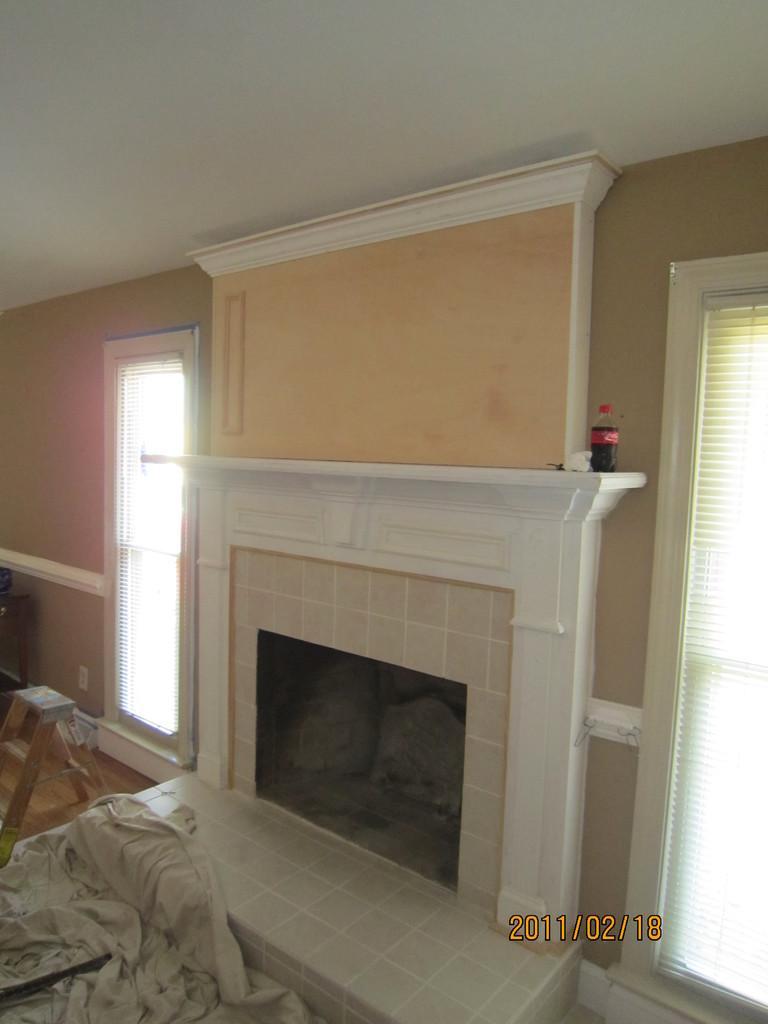Please provide a concise description of this image. At the bottom of the image there is date, in this image there is a fireplace, on the fireplace platform, there are some objects, beside the fireplace there are windows with curtains, in front of that there is a ladder and a cloth on the floor and there is some other object. 